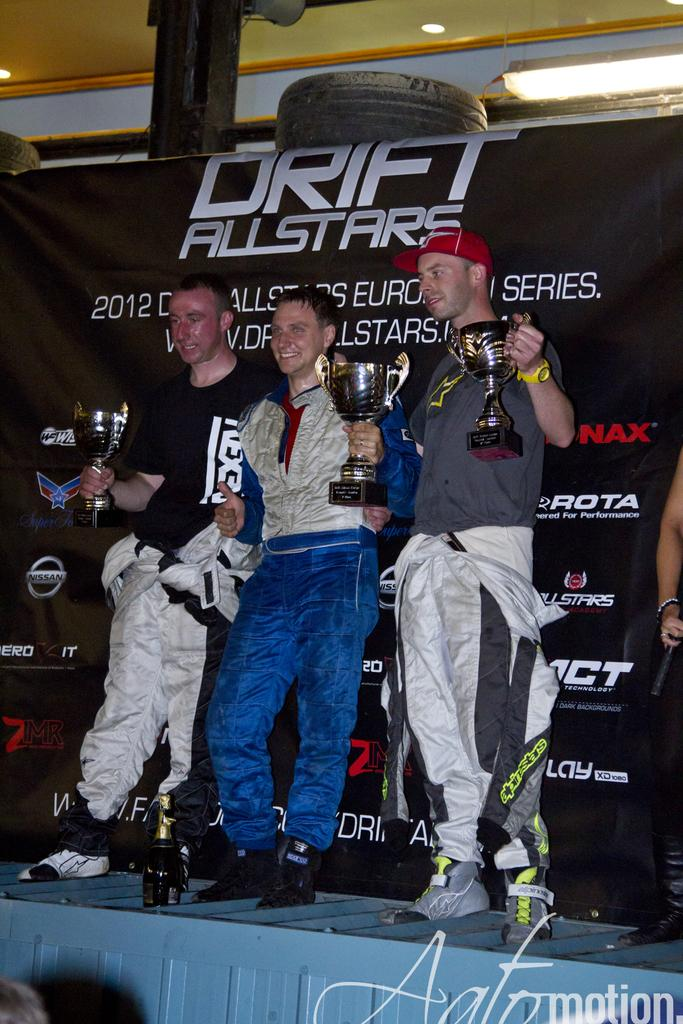<image>
Summarize the visual content of the image. Three men display trophies at a Drift Allstars event 